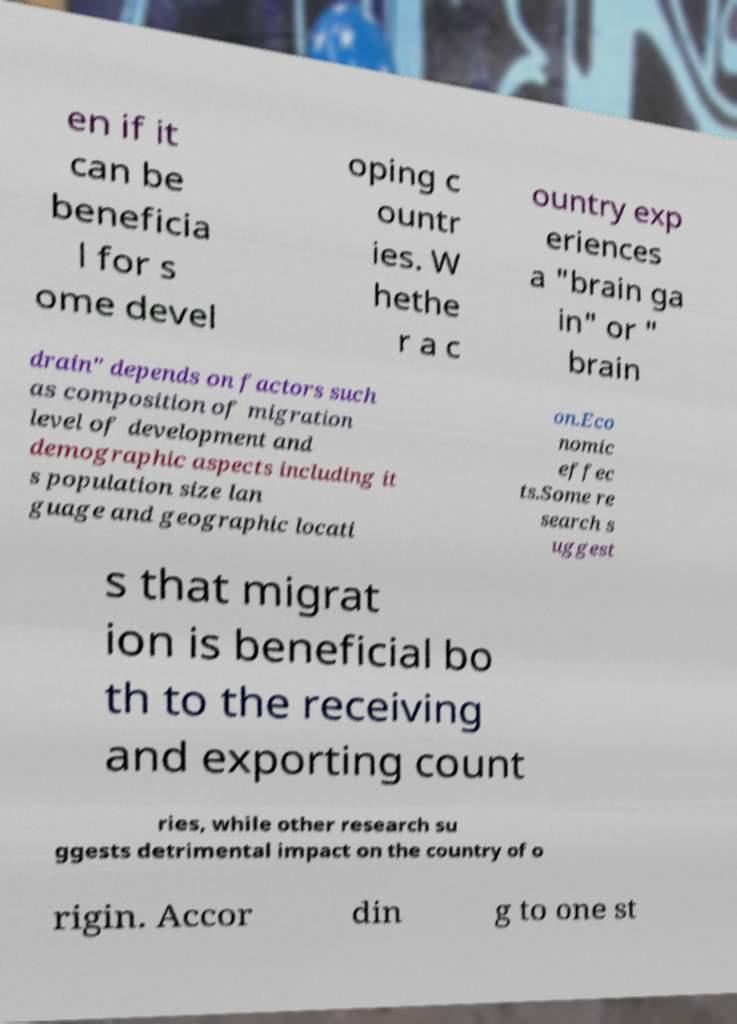Could you extract and type out the text from this image? en if it can be beneficia l for s ome devel oping c ountr ies. W hethe r a c ountry exp eriences a "brain ga in" or " brain drain" depends on factors such as composition of migration level of development and demographic aspects including it s population size lan guage and geographic locati on.Eco nomic effec ts.Some re search s uggest s that migrat ion is beneficial bo th to the receiving and exporting count ries, while other research su ggests detrimental impact on the country of o rigin. Accor din g to one st 